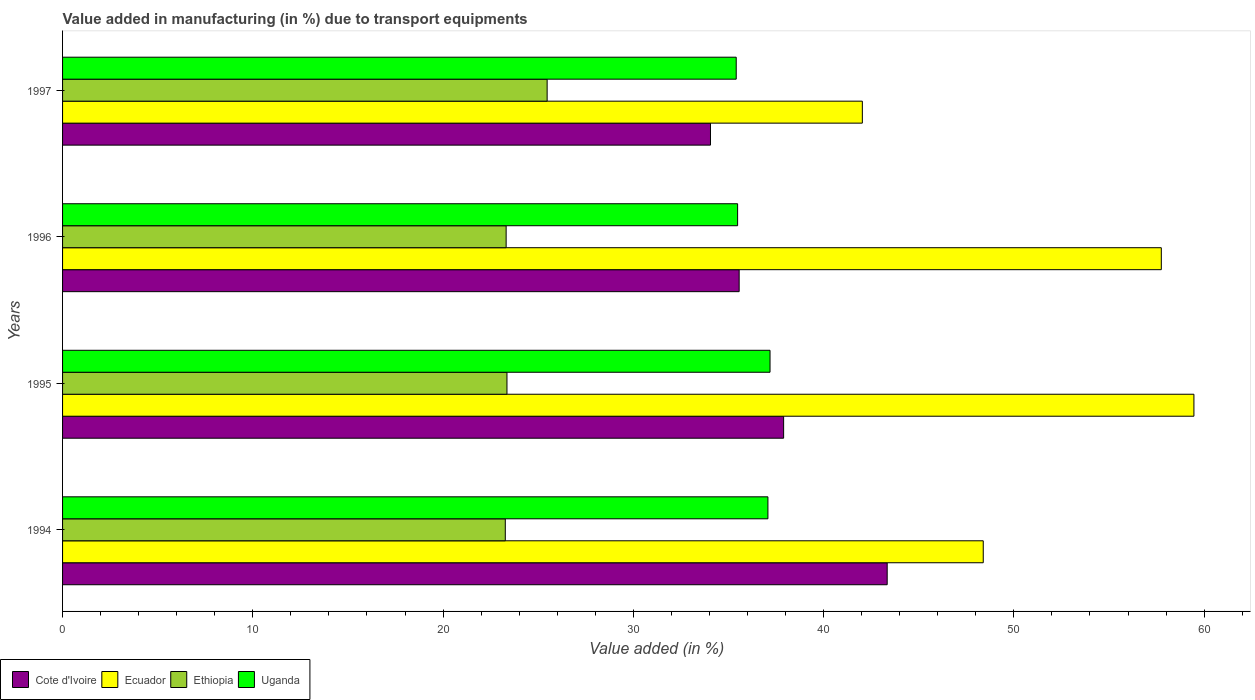Are the number of bars on each tick of the Y-axis equal?
Offer a very short reply. Yes. How many bars are there on the 1st tick from the top?
Your answer should be compact. 4. What is the label of the 3rd group of bars from the top?
Your response must be concise. 1995. What is the percentage of value added in manufacturing due to transport equipments in Ethiopia in 1994?
Provide a succinct answer. 23.27. Across all years, what is the maximum percentage of value added in manufacturing due to transport equipments in Cote d'Ivoire?
Offer a terse response. 43.34. Across all years, what is the minimum percentage of value added in manufacturing due to transport equipments in Ethiopia?
Ensure brevity in your answer.  23.27. What is the total percentage of value added in manufacturing due to transport equipments in Uganda in the graph?
Offer a very short reply. 145.14. What is the difference between the percentage of value added in manufacturing due to transport equipments in Ecuador in 1995 and that in 1997?
Your answer should be very brief. 17.43. What is the difference between the percentage of value added in manufacturing due to transport equipments in Ecuador in 1996 and the percentage of value added in manufacturing due to transport equipments in Uganda in 1997?
Make the answer very short. 22.34. What is the average percentage of value added in manufacturing due to transport equipments in Cote d'Ivoire per year?
Offer a very short reply. 37.71. In the year 1996, what is the difference between the percentage of value added in manufacturing due to transport equipments in Ethiopia and percentage of value added in manufacturing due to transport equipments in Cote d'Ivoire?
Your answer should be very brief. -12.25. In how many years, is the percentage of value added in manufacturing due to transport equipments in Cote d'Ivoire greater than 54 %?
Offer a very short reply. 0. What is the ratio of the percentage of value added in manufacturing due to transport equipments in Uganda in 1995 to that in 1997?
Your answer should be compact. 1.05. Is the percentage of value added in manufacturing due to transport equipments in Cote d'Ivoire in 1995 less than that in 1997?
Your answer should be compact. No. What is the difference between the highest and the second highest percentage of value added in manufacturing due to transport equipments in Cote d'Ivoire?
Your answer should be compact. 5.44. What is the difference between the highest and the lowest percentage of value added in manufacturing due to transport equipments in Uganda?
Offer a terse response. 1.78. In how many years, is the percentage of value added in manufacturing due to transport equipments in Ecuador greater than the average percentage of value added in manufacturing due to transport equipments in Ecuador taken over all years?
Keep it short and to the point. 2. Is the sum of the percentage of value added in manufacturing due to transport equipments in Ethiopia in 1994 and 1997 greater than the maximum percentage of value added in manufacturing due to transport equipments in Cote d'Ivoire across all years?
Give a very brief answer. Yes. What does the 3rd bar from the top in 1997 represents?
Make the answer very short. Ecuador. What does the 1st bar from the bottom in 1995 represents?
Provide a succinct answer. Cote d'Ivoire. Is it the case that in every year, the sum of the percentage of value added in manufacturing due to transport equipments in Ecuador and percentage of value added in manufacturing due to transport equipments in Cote d'Ivoire is greater than the percentage of value added in manufacturing due to transport equipments in Ethiopia?
Your answer should be very brief. Yes. Are all the bars in the graph horizontal?
Your response must be concise. Yes. How many years are there in the graph?
Offer a terse response. 4. What is the difference between two consecutive major ticks on the X-axis?
Ensure brevity in your answer.  10. Does the graph contain grids?
Offer a terse response. No. Where does the legend appear in the graph?
Give a very brief answer. Bottom left. What is the title of the graph?
Give a very brief answer. Value added in manufacturing (in %) due to transport equipments. Does "Argentina" appear as one of the legend labels in the graph?
Your answer should be very brief. No. What is the label or title of the X-axis?
Provide a succinct answer. Value added (in %). What is the Value added (in %) of Cote d'Ivoire in 1994?
Provide a short and direct response. 43.34. What is the Value added (in %) in Ecuador in 1994?
Offer a very short reply. 48.39. What is the Value added (in %) in Ethiopia in 1994?
Provide a short and direct response. 23.27. What is the Value added (in %) in Uganda in 1994?
Your response must be concise. 37.07. What is the Value added (in %) of Cote d'Ivoire in 1995?
Ensure brevity in your answer.  37.9. What is the Value added (in %) of Ecuador in 1995?
Make the answer very short. 59.46. What is the Value added (in %) of Ethiopia in 1995?
Offer a terse response. 23.36. What is the Value added (in %) of Uganda in 1995?
Your answer should be very brief. 37.18. What is the Value added (in %) in Cote d'Ivoire in 1996?
Offer a very short reply. 35.56. What is the Value added (in %) of Ecuador in 1996?
Ensure brevity in your answer.  57.75. What is the Value added (in %) in Ethiopia in 1996?
Make the answer very short. 23.31. What is the Value added (in %) of Uganda in 1996?
Offer a very short reply. 35.48. What is the Value added (in %) of Cote d'Ivoire in 1997?
Offer a terse response. 34.05. What is the Value added (in %) in Ecuador in 1997?
Make the answer very short. 42.04. What is the Value added (in %) of Ethiopia in 1997?
Give a very brief answer. 25.47. What is the Value added (in %) in Uganda in 1997?
Your answer should be very brief. 35.41. Across all years, what is the maximum Value added (in %) of Cote d'Ivoire?
Provide a succinct answer. 43.34. Across all years, what is the maximum Value added (in %) in Ecuador?
Ensure brevity in your answer.  59.46. Across all years, what is the maximum Value added (in %) of Ethiopia?
Offer a very short reply. 25.47. Across all years, what is the maximum Value added (in %) of Uganda?
Offer a terse response. 37.18. Across all years, what is the minimum Value added (in %) of Cote d'Ivoire?
Make the answer very short. 34.05. Across all years, what is the minimum Value added (in %) of Ecuador?
Give a very brief answer. 42.04. Across all years, what is the minimum Value added (in %) of Ethiopia?
Give a very brief answer. 23.27. Across all years, what is the minimum Value added (in %) of Uganda?
Your response must be concise. 35.41. What is the total Value added (in %) in Cote d'Ivoire in the graph?
Give a very brief answer. 150.85. What is the total Value added (in %) of Ecuador in the graph?
Keep it short and to the point. 207.64. What is the total Value added (in %) of Ethiopia in the graph?
Provide a succinct answer. 95.41. What is the total Value added (in %) in Uganda in the graph?
Ensure brevity in your answer.  145.14. What is the difference between the Value added (in %) in Cote d'Ivoire in 1994 and that in 1995?
Ensure brevity in your answer.  5.44. What is the difference between the Value added (in %) in Ecuador in 1994 and that in 1995?
Your response must be concise. -11.07. What is the difference between the Value added (in %) of Ethiopia in 1994 and that in 1995?
Your response must be concise. -0.09. What is the difference between the Value added (in %) of Uganda in 1994 and that in 1995?
Make the answer very short. -0.11. What is the difference between the Value added (in %) in Cote d'Ivoire in 1994 and that in 1996?
Make the answer very short. 7.78. What is the difference between the Value added (in %) of Ecuador in 1994 and that in 1996?
Make the answer very short. -9.36. What is the difference between the Value added (in %) of Ethiopia in 1994 and that in 1996?
Offer a very short reply. -0.04. What is the difference between the Value added (in %) of Uganda in 1994 and that in 1996?
Provide a short and direct response. 1.59. What is the difference between the Value added (in %) in Cote d'Ivoire in 1994 and that in 1997?
Your answer should be compact. 9.29. What is the difference between the Value added (in %) in Ecuador in 1994 and that in 1997?
Make the answer very short. 6.35. What is the difference between the Value added (in %) of Ethiopia in 1994 and that in 1997?
Provide a succinct answer. -2.2. What is the difference between the Value added (in %) in Uganda in 1994 and that in 1997?
Provide a short and direct response. 1.67. What is the difference between the Value added (in %) in Cote d'Ivoire in 1995 and that in 1996?
Keep it short and to the point. 2.34. What is the difference between the Value added (in %) of Ecuador in 1995 and that in 1996?
Give a very brief answer. 1.71. What is the difference between the Value added (in %) of Ethiopia in 1995 and that in 1996?
Offer a very short reply. 0.04. What is the difference between the Value added (in %) of Uganda in 1995 and that in 1996?
Ensure brevity in your answer.  1.7. What is the difference between the Value added (in %) of Cote d'Ivoire in 1995 and that in 1997?
Make the answer very short. 3.84. What is the difference between the Value added (in %) of Ecuador in 1995 and that in 1997?
Offer a terse response. 17.43. What is the difference between the Value added (in %) of Ethiopia in 1995 and that in 1997?
Provide a succinct answer. -2.11. What is the difference between the Value added (in %) of Uganda in 1995 and that in 1997?
Provide a short and direct response. 1.78. What is the difference between the Value added (in %) in Cote d'Ivoire in 1996 and that in 1997?
Make the answer very short. 1.51. What is the difference between the Value added (in %) in Ecuador in 1996 and that in 1997?
Offer a very short reply. 15.71. What is the difference between the Value added (in %) in Ethiopia in 1996 and that in 1997?
Your answer should be very brief. -2.16. What is the difference between the Value added (in %) of Uganda in 1996 and that in 1997?
Ensure brevity in your answer.  0.07. What is the difference between the Value added (in %) of Cote d'Ivoire in 1994 and the Value added (in %) of Ecuador in 1995?
Give a very brief answer. -16.12. What is the difference between the Value added (in %) of Cote d'Ivoire in 1994 and the Value added (in %) of Ethiopia in 1995?
Keep it short and to the point. 19.98. What is the difference between the Value added (in %) in Cote d'Ivoire in 1994 and the Value added (in %) in Uganda in 1995?
Offer a very short reply. 6.16. What is the difference between the Value added (in %) in Ecuador in 1994 and the Value added (in %) in Ethiopia in 1995?
Keep it short and to the point. 25.03. What is the difference between the Value added (in %) of Ecuador in 1994 and the Value added (in %) of Uganda in 1995?
Offer a very short reply. 11.21. What is the difference between the Value added (in %) in Ethiopia in 1994 and the Value added (in %) in Uganda in 1995?
Your answer should be compact. -13.91. What is the difference between the Value added (in %) of Cote d'Ivoire in 1994 and the Value added (in %) of Ecuador in 1996?
Offer a terse response. -14.41. What is the difference between the Value added (in %) in Cote d'Ivoire in 1994 and the Value added (in %) in Ethiopia in 1996?
Provide a short and direct response. 20.03. What is the difference between the Value added (in %) in Cote d'Ivoire in 1994 and the Value added (in %) in Uganda in 1996?
Your answer should be very brief. 7.86. What is the difference between the Value added (in %) of Ecuador in 1994 and the Value added (in %) of Ethiopia in 1996?
Make the answer very short. 25.08. What is the difference between the Value added (in %) of Ecuador in 1994 and the Value added (in %) of Uganda in 1996?
Provide a succinct answer. 12.91. What is the difference between the Value added (in %) of Ethiopia in 1994 and the Value added (in %) of Uganda in 1996?
Provide a succinct answer. -12.21. What is the difference between the Value added (in %) in Cote d'Ivoire in 1994 and the Value added (in %) in Ecuador in 1997?
Your response must be concise. 1.31. What is the difference between the Value added (in %) in Cote d'Ivoire in 1994 and the Value added (in %) in Ethiopia in 1997?
Offer a very short reply. 17.87. What is the difference between the Value added (in %) of Cote d'Ivoire in 1994 and the Value added (in %) of Uganda in 1997?
Your answer should be compact. 7.93. What is the difference between the Value added (in %) of Ecuador in 1994 and the Value added (in %) of Ethiopia in 1997?
Your answer should be compact. 22.92. What is the difference between the Value added (in %) in Ecuador in 1994 and the Value added (in %) in Uganda in 1997?
Keep it short and to the point. 12.98. What is the difference between the Value added (in %) of Ethiopia in 1994 and the Value added (in %) of Uganda in 1997?
Provide a succinct answer. -12.14. What is the difference between the Value added (in %) of Cote d'Ivoire in 1995 and the Value added (in %) of Ecuador in 1996?
Offer a very short reply. -19.85. What is the difference between the Value added (in %) in Cote d'Ivoire in 1995 and the Value added (in %) in Ethiopia in 1996?
Offer a very short reply. 14.59. What is the difference between the Value added (in %) in Cote d'Ivoire in 1995 and the Value added (in %) in Uganda in 1996?
Your answer should be very brief. 2.42. What is the difference between the Value added (in %) of Ecuador in 1995 and the Value added (in %) of Ethiopia in 1996?
Your response must be concise. 36.15. What is the difference between the Value added (in %) of Ecuador in 1995 and the Value added (in %) of Uganda in 1996?
Keep it short and to the point. 23.98. What is the difference between the Value added (in %) of Ethiopia in 1995 and the Value added (in %) of Uganda in 1996?
Your answer should be very brief. -12.12. What is the difference between the Value added (in %) of Cote d'Ivoire in 1995 and the Value added (in %) of Ecuador in 1997?
Keep it short and to the point. -4.14. What is the difference between the Value added (in %) in Cote d'Ivoire in 1995 and the Value added (in %) in Ethiopia in 1997?
Your response must be concise. 12.43. What is the difference between the Value added (in %) of Cote d'Ivoire in 1995 and the Value added (in %) of Uganda in 1997?
Your response must be concise. 2.49. What is the difference between the Value added (in %) of Ecuador in 1995 and the Value added (in %) of Ethiopia in 1997?
Give a very brief answer. 33.99. What is the difference between the Value added (in %) in Ecuador in 1995 and the Value added (in %) in Uganda in 1997?
Your answer should be compact. 24.06. What is the difference between the Value added (in %) in Ethiopia in 1995 and the Value added (in %) in Uganda in 1997?
Your answer should be compact. -12.05. What is the difference between the Value added (in %) in Cote d'Ivoire in 1996 and the Value added (in %) in Ecuador in 1997?
Offer a very short reply. -6.47. What is the difference between the Value added (in %) in Cote d'Ivoire in 1996 and the Value added (in %) in Ethiopia in 1997?
Provide a succinct answer. 10.09. What is the difference between the Value added (in %) of Cote d'Ivoire in 1996 and the Value added (in %) of Uganda in 1997?
Your response must be concise. 0.15. What is the difference between the Value added (in %) in Ecuador in 1996 and the Value added (in %) in Ethiopia in 1997?
Give a very brief answer. 32.28. What is the difference between the Value added (in %) of Ecuador in 1996 and the Value added (in %) of Uganda in 1997?
Make the answer very short. 22.34. What is the difference between the Value added (in %) in Ethiopia in 1996 and the Value added (in %) in Uganda in 1997?
Make the answer very short. -12.09. What is the average Value added (in %) in Cote d'Ivoire per year?
Your answer should be very brief. 37.71. What is the average Value added (in %) in Ecuador per year?
Give a very brief answer. 51.91. What is the average Value added (in %) in Ethiopia per year?
Offer a very short reply. 23.85. What is the average Value added (in %) in Uganda per year?
Offer a terse response. 36.29. In the year 1994, what is the difference between the Value added (in %) in Cote d'Ivoire and Value added (in %) in Ecuador?
Provide a short and direct response. -5.05. In the year 1994, what is the difference between the Value added (in %) of Cote d'Ivoire and Value added (in %) of Ethiopia?
Make the answer very short. 20.07. In the year 1994, what is the difference between the Value added (in %) in Cote d'Ivoire and Value added (in %) in Uganda?
Keep it short and to the point. 6.27. In the year 1994, what is the difference between the Value added (in %) of Ecuador and Value added (in %) of Ethiopia?
Your answer should be compact. 25.12. In the year 1994, what is the difference between the Value added (in %) in Ecuador and Value added (in %) in Uganda?
Ensure brevity in your answer.  11.32. In the year 1994, what is the difference between the Value added (in %) of Ethiopia and Value added (in %) of Uganda?
Your answer should be compact. -13.8. In the year 1995, what is the difference between the Value added (in %) of Cote d'Ivoire and Value added (in %) of Ecuador?
Keep it short and to the point. -21.56. In the year 1995, what is the difference between the Value added (in %) in Cote d'Ivoire and Value added (in %) in Ethiopia?
Ensure brevity in your answer.  14.54. In the year 1995, what is the difference between the Value added (in %) in Cote d'Ivoire and Value added (in %) in Uganda?
Your response must be concise. 0.72. In the year 1995, what is the difference between the Value added (in %) in Ecuador and Value added (in %) in Ethiopia?
Offer a terse response. 36.11. In the year 1995, what is the difference between the Value added (in %) of Ecuador and Value added (in %) of Uganda?
Make the answer very short. 22.28. In the year 1995, what is the difference between the Value added (in %) in Ethiopia and Value added (in %) in Uganda?
Keep it short and to the point. -13.83. In the year 1996, what is the difference between the Value added (in %) of Cote d'Ivoire and Value added (in %) of Ecuador?
Your answer should be compact. -22.19. In the year 1996, what is the difference between the Value added (in %) in Cote d'Ivoire and Value added (in %) in Ethiopia?
Your answer should be compact. 12.25. In the year 1996, what is the difference between the Value added (in %) of Cote d'Ivoire and Value added (in %) of Uganda?
Provide a short and direct response. 0.08. In the year 1996, what is the difference between the Value added (in %) of Ecuador and Value added (in %) of Ethiopia?
Your answer should be compact. 34.44. In the year 1996, what is the difference between the Value added (in %) in Ecuador and Value added (in %) in Uganda?
Provide a succinct answer. 22.27. In the year 1996, what is the difference between the Value added (in %) of Ethiopia and Value added (in %) of Uganda?
Offer a terse response. -12.17. In the year 1997, what is the difference between the Value added (in %) of Cote d'Ivoire and Value added (in %) of Ecuador?
Your answer should be compact. -7.98. In the year 1997, what is the difference between the Value added (in %) of Cote d'Ivoire and Value added (in %) of Ethiopia?
Keep it short and to the point. 8.58. In the year 1997, what is the difference between the Value added (in %) in Cote d'Ivoire and Value added (in %) in Uganda?
Your answer should be compact. -1.35. In the year 1997, what is the difference between the Value added (in %) in Ecuador and Value added (in %) in Ethiopia?
Your answer should be compact. 16.57. In the year 1997, what is the difference between the Value added (in %) of Ecuador and Value added (in %) of Uganda?
Make the answer very short. 6.63. In the year 1997, what is the difference between the Value added (in %) in Ethiopia and Value added (in %) in Uganda?
Provide a succinct answer. -9.94. What is the ratio of the Value added (in %) in Cote d'Ivoire in 1994 to that in 1995?
Your answer should be very brief. 1.14. What is the ratio of the Value added (in %) of Ecuador in 1994 to that in 1995?
Make the answer very short. 0.81. What is the ratio of the Value added (in %) in Ethiopia in 1994 to that in 1995?
Ensure brevity in your answer.  1. What is the ratio of the Value added (in %) in Cote d'Ivoire in 1994 to that in 1996?
Your answer should be compact. 1.22. What is the ratio of the Value added (in %) of Ecuador in 1994 to that in 1996?
Provide a short and direct response. 0.84. What is the ratio of the Value added (in %) in Ethiopia in 1994 to that in 1996?
Offer a terse response. 1. What is the ratio of the Value added (in %) in Uganda in 1994 to that in 1996?
Provide a short and direct response. 1.04. What is the ratio of the Value added (in %) of Cote d'Ivoire in 1994 to that in 1997?
Ensure brevity in your answer.  1.27. What is the ratio of the Value added (in %) of Ecuador in 1994 to that in 1997?
Make the answer very short. 1.15. What is the ratio of the Value added (in %) of Ethiopia in 1994 to that in 1997?
Provide a succinct answer. 0.91. What is the ratio of the Value added (in %) in Uganda in 1994 to that in 1997?
Your answer should be very brief. 1.05. What is the ratio of the Value added (in %) in Cote d'Ivoire in 1995 to that in 1996?
Ensure brevity in your answer.  1.07. What is the ratio of the Value added (in %) of Ecuador in 1995 to that in 1996?
Your answer should be very brief. 1.03. What is the ratio of the Value added (in %) in Ethiopia in 1995 to that in 1996?
Offer a very short reply. 1. What is the ratio of the Value added (in %) of Uganda in 1995 to that in 1996?
Your response must be concise. 1.05. What is the ratio of the Value added (in %) in Cote d'Ivoire in 1995 to that in 1997?
Ensure brevity in your answer.  1.11. What is the ratio of the Value added (in %) in Ecuador in 1995 to that in 1997?
Offer a very short reply. 1.41. What is the ratio of the Value added (in %) of Ethiopia in 1995 to that in 1997?
Provide a succinct answer. 0.92. What is the ratio of the Value added (in %) of Uganda in 1995 to that in 1997?
Make the answer very short. 1.05. What is the ratio of the Value added (in %) of Cote d'Ivoire in 1996 to that in 1997?
Your response must be concise. 1.04. What is the ratio of the Value added (in %) in Ecuador in 1996 to that in 1997?
Your response must be concise. 1.37. What is the ratio of the Value added (in %) in Ethiopia in 1996 to that in 1997?
Keep it short and to the point. 0.92. What is the ratio of the Value added (in %) of Uganda in 1996 to that in 1997?
Keep it short and to the point. 1. What is the difference between the highest and the second highest Value added (in %) of Cote d'Ivoire?
Provide a succinct answer. 5.44. What is the difference between the highest and the second highest Value added (in %) of Ecuador?
Give a very brief answer. 1.71. What is the difference between the highest and the second highest Value added (in %) in Ethiopia?
Your answer should be very brief. 2.11. What is the difference between the highest and the second highest Value added (in %) of Uganda?
Your response must be concise. 0.11. What is the difference between the highest and the lowest Value added (in %) in Cote d'Ivoire?
Provide a short and direct response. 9.29. What is the difference between the highest and the lowest Value added (in %) of Ecuador?
Your response must be concise. 17.43. What is the difference between the highest and the lowest Value added (in %) in Ethiopia?
Your answer should be compact. 2.2. What is the difference between the highest and the lowest Value added (in %) of Uganda?
Give a very brief answer. 1.78. 